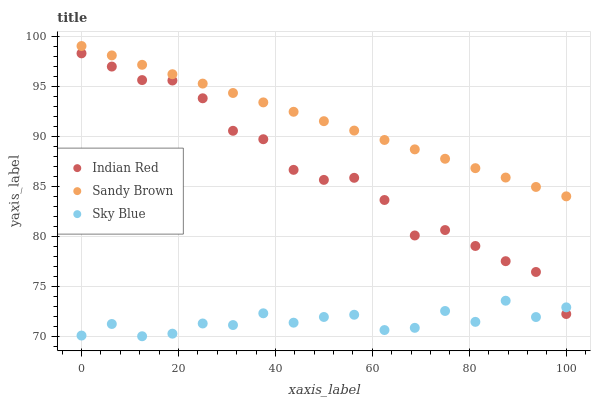Does Sky Blue have the minimum area under the curve?
Answer yes or no. Yes. Does Sandy Brown have the maximum area under the curve?
Answer yes or no. Yes. Does Indian Red have the minimum area under the curve?
Answer yes or no. No. Does Indian Red have the maximum area under the curve?
Answer yes or no. No. Is Sandy Brown the smoothest?
Answer yes or no. Yes. Is Sky Blue the roughest?
Answer yes or no. Yes. Is Indian Red the smoothest?
Answer yes or no. No. Is Indian Red the roughest?
Answer yes or no. No. Does Sky Blue have the lowest value?
Answer yes or no. Yes. Does Indian Red have the lowest value?
Answer yes or no. No. Does Sandy Brown have the highest value?
Answer yes or no. Yes. Does Indian Red have the highest value?
Answer yes or no. No. Is Indian Red less than Sandy Brown?
Answer yes or no. Yes. Is Sandy Brown greater than Indian Red?
Answer yes or no. Yes. Does Sky Blue intersect Indian Red?
Answer yes or no. Yes. Is Sky Blue less than Indian Red?
Answer yes or no. No. Is Sky Blue greater than Indian Red?
Answer yes or no. No. Does Indian Red intersect Sandy Brown?
Answer yes or no. No. 